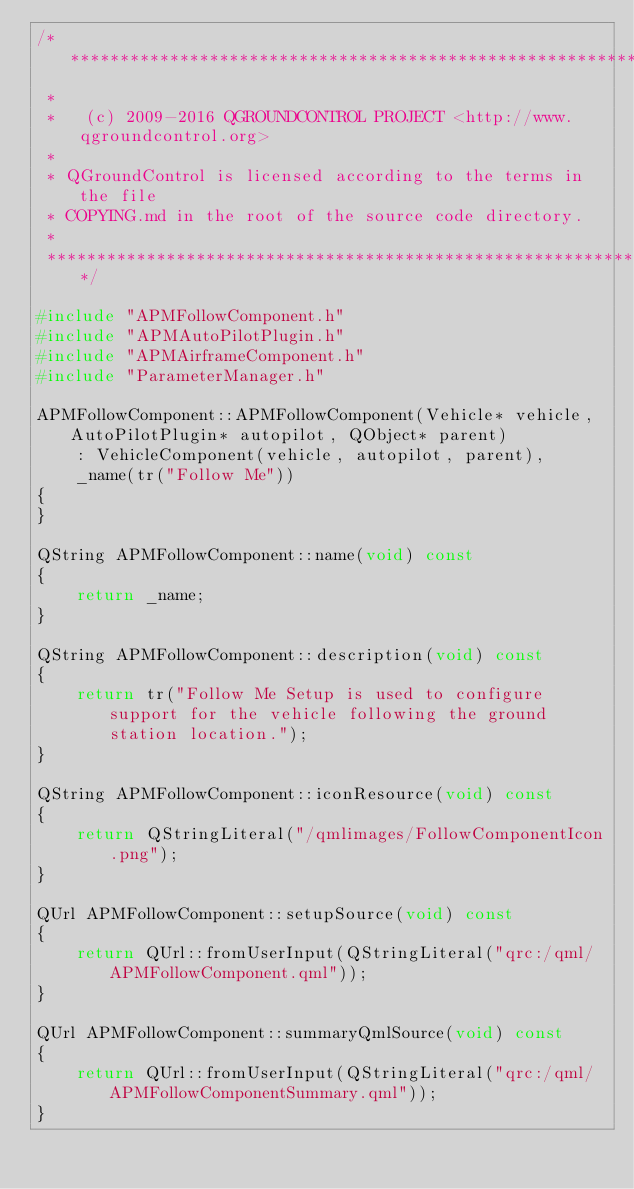<code> <loc_0><loc_0><loc_500><loc_500><_C++_>/****************************************************************************
 *
 *   (c) 2009-2016 QGROUNDCONTROL PROJECT <http://www.qgroundcontrol.org>
 *
 * QGroundControl is licensed according to the terms in the file
 * COPYING.md in the root of the source code directory.
 *
 ****************************************************************************/

#include "APMFollowComponent.h"
#include "APMAutoPilotPlugin.h"
#include "APMAirframeComponent.h"
#include "ParameterManager.h"

APMFollowComponent::APMFollowComponent(Vehicle* vehicle, AutoPilotPlugin* autopilot, QObject* parent)
    : VehicleComponent(vehicle, autopilot, parent),
    _name(tr("Follow Me"))
{
}

QString APMFollowComponent::name(void) const
{
    return _name;
}

QString APMFollowComponent::description(void) const
{
    return tr("Follow Me Setup is used to configure support for the vehicle following the ground station location.");
}

QString APMFollowComponent::iconResource(void) const
{
    return QStringLiteral("/qmlimages/FollowComponentIcon.png");
}

QUrl APMFollowComponent::setupSource(void) const
{
    return QUrl::fromUserInput(QStringLiteral("qrc:/qml/APMFollowComponent.qml"));
}

QUrl APMFollowComponent::summaryQmlSource(void) const
{
    return QUrl::fromUserInput(QStringLiteral("qrc:/qml/APMFollowComponentSummary.qml"));
}
</code> 